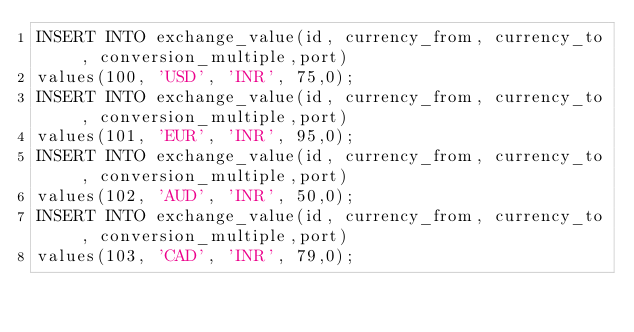Convert code to text. <code><loc_0><loc_0><loc_500><loc_500><_SQL_>INSERT INTO exchange_value(id, currency_from, currency_to , conversion_multiple,port)
values(100, 'USD', 'INR', 75,0);
INSERT INTO exchange_value(id, currency_from, currency_to , conversion_multiple,port)
values(101, 'EUR', 'INR', 95,0);
INSERT INTO exchange_value(id, currency_from, currency_to , conversion_multiple,port)
values(102, 'AUD', 'INR', 50,0);
INSERT INTO exchange_value(id, currency_from, currency_to , conversion_multiple,port)
values(103, 'CAD', 'INR', 79,0);</code> 